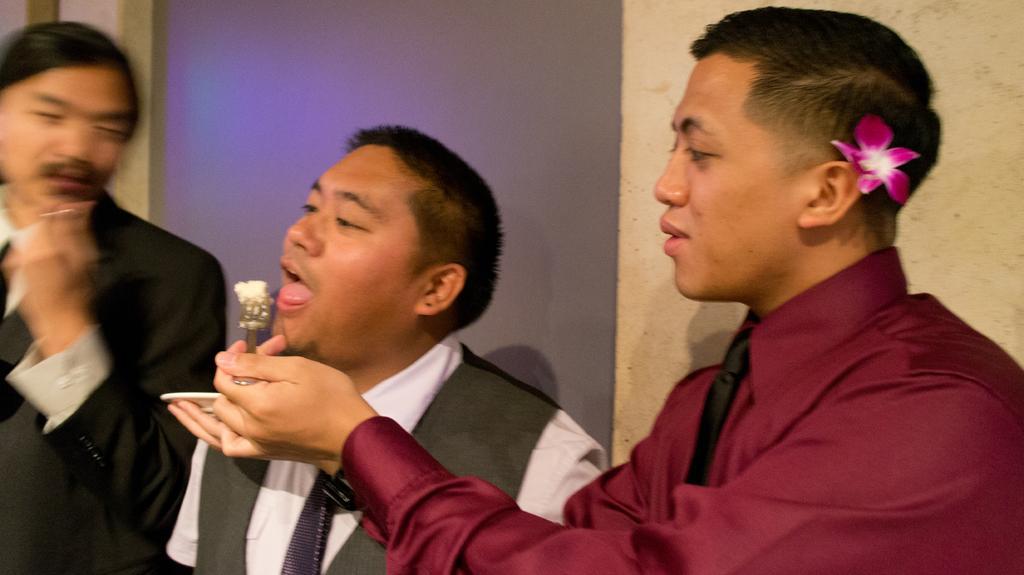Could you give a brief overview of what you see in this image? In the image we can see three men wearing clothes. Here we can see a flower, pink and white in color. The right side man is holding a spoon in one hand and on the other hand there is a plate. Here we can see the wall and the left side image is slightly blurred. 